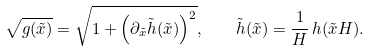<formula> <loc_0><loc_0><loc_500><loc_500>\sqrt { g ( \tilde { x } ) } = \sqrt { 1 + \left ( \partial _ { \tilde { x } } \tilde { h } ( \tilde { x } ) \right ) ^ { 2 } } , \quad \tilde { h } ( \tilde { x } ) = \frac { 1 } { H } \, h ( \tilde { x } H ) .</formula> 